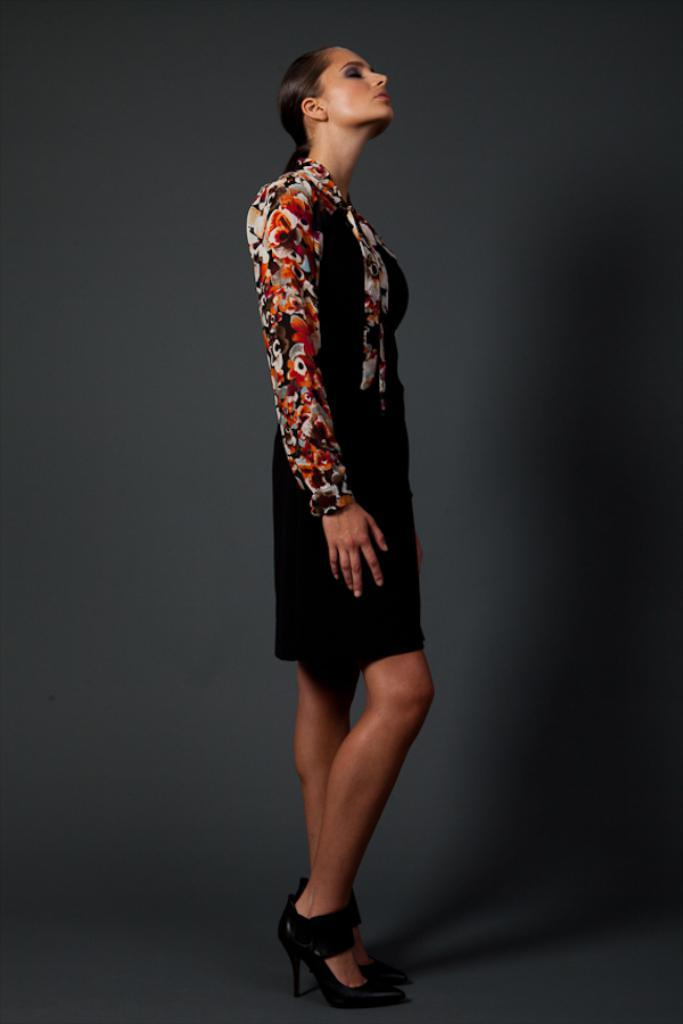Who is the main subject in the image? There is a woman in the image. What is the woman wearing? The woman is wearing a black dress. What color is the background of the image? The background of the image is gray in color. Are there any cobwebs visible in the image? There are no cobwebs present in the image. What is the woman's desire in the image? The image does not provide any information about the woman's desires or emotions. Can you hear any drums in the image? The image is a still photograph, so there is no sound or music present. 